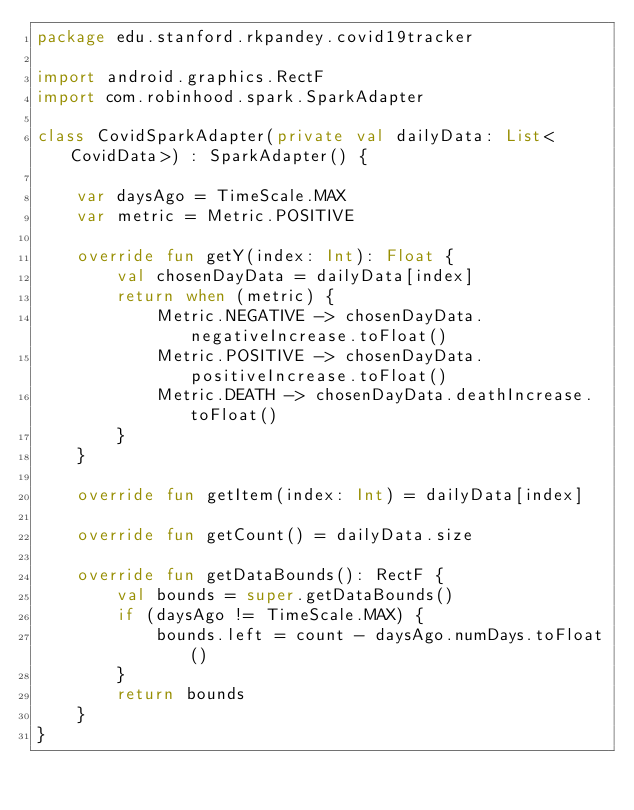Convert code to text. <code><loc_0><loc_0><loc_500><loc_500><_Kotlin_>package edu.stanford.rkpandey.covid19tracker

import android.graphics.RectF
import com.robinhood.spark.SparkAdapter

class CovidSparkAdapter(private val dailyData: List<CovidData>) : SparkAdapter() {

    var daysAgo = TimeScale.MAX
    var metric = Metric.POSITIVE

    override fun getY(index: Int): Float {
        val chosenDayData = dailyData[index]
        return when (metric) {
            Metric.NEGATIVE -> chosenDayData.negativeIncrease.toFloat()
            Metric.POSITIVE -> chosenDayData.positiveIncrease.toFloat()
            Metric.DEATH -> chosenDayData.deathIncrease.toFloat()
        }
    }

    override fun getItem(index: Int) = dailyData[index]

    override fun getCount() = dailyData.size

    override fun getDataBounds(): RectF {
        val bounds = super.getDataBounds()
        if (daysAgo != TimeScale.MAX) {
            bounds.left = count - daysAgo.numDays.toFloat()
        }
        return bounds
    }
}</code> 